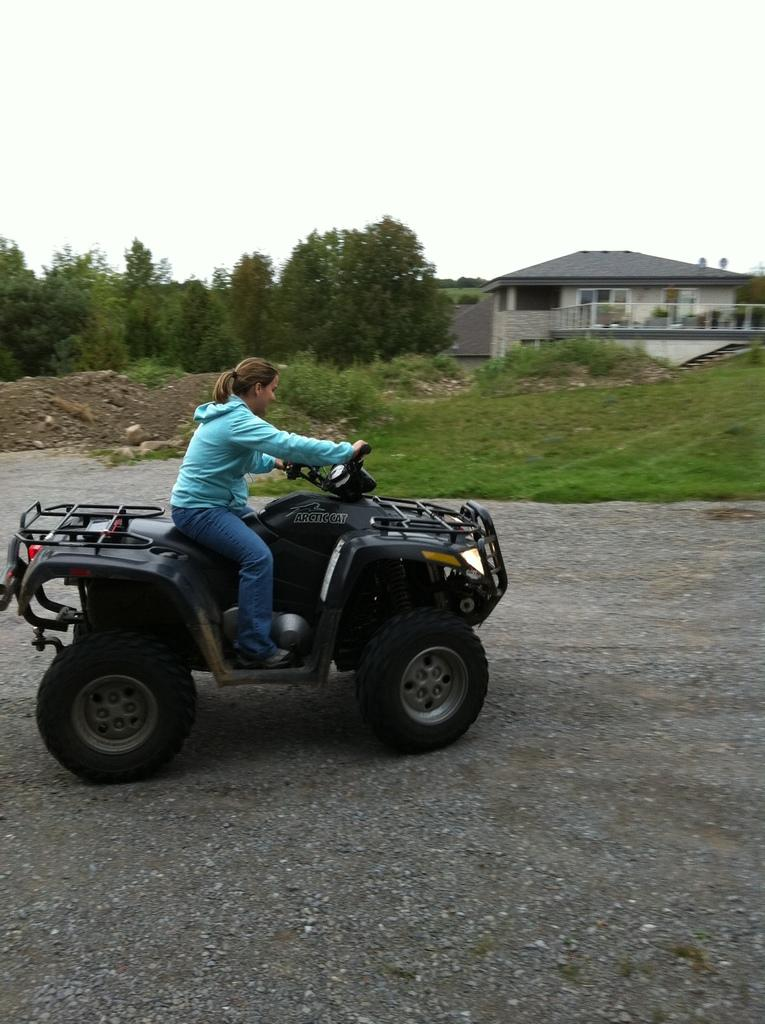Who is present in the image? There is a woman in the image. What is the woman wearing? The woman is wearing clothes. Where is the woman sitting? The woman is sitting on a vehicle. What can be seen in the background of the image? There is a road, grass, trees, and a house visible in the image. What is visible in the sky? The sky is visible in the image. What type of advice is the woman giving in the image? There is no indication in the image that the woman is giving advice, so it cannot be determined from the picture. 